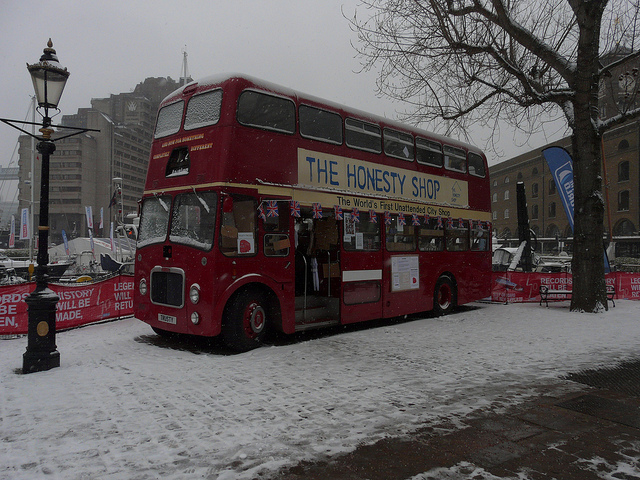Please transcribe the text in this image. THE HONESTY SHOP EN MADE BE 